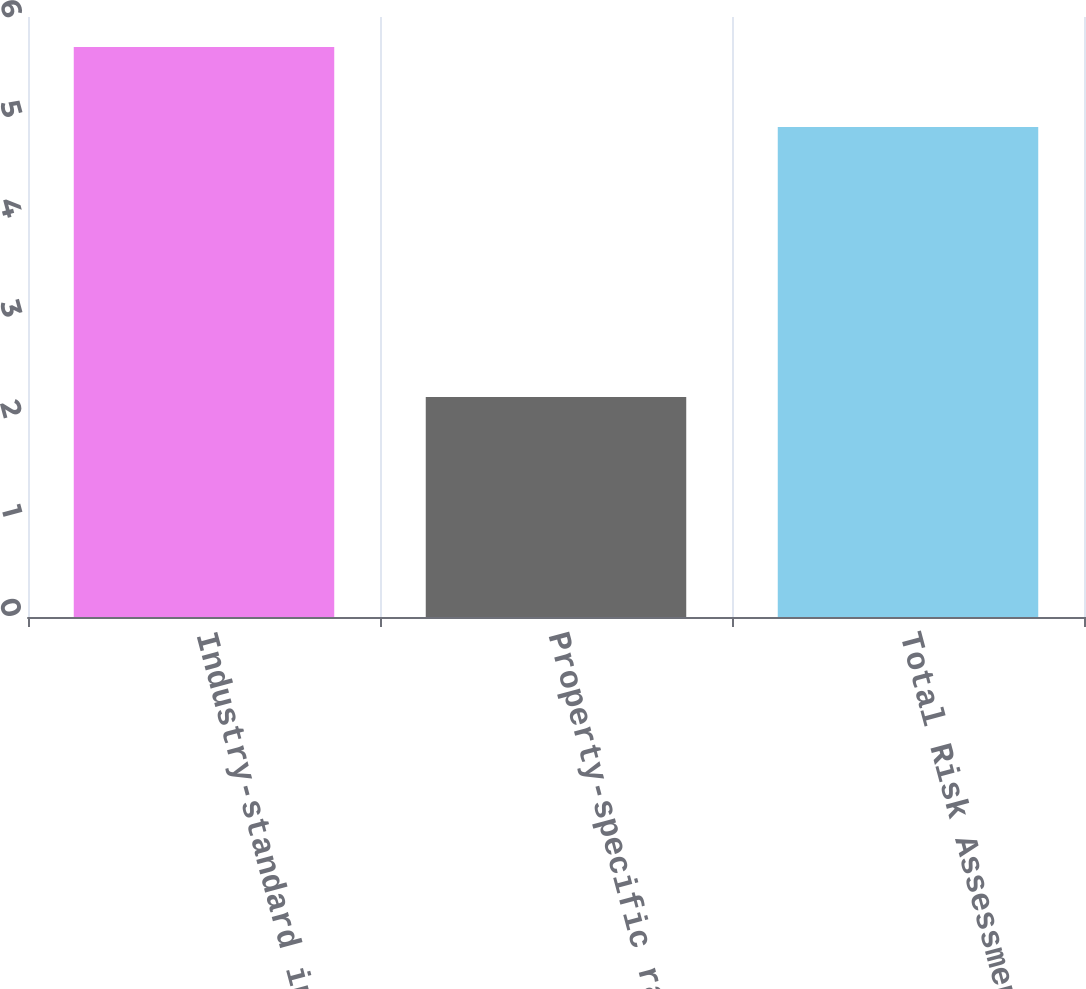Convert chart. <chart><loc_0><loc_0><loc_500><loc_500><bar_chart><fcel>Industry-standard insurance<fcel>Property-specific rating and<fcel>Total Risk Assessment<nl><fcel>5.7<fcel>2.2<fcel>4.9<nl></chart> 